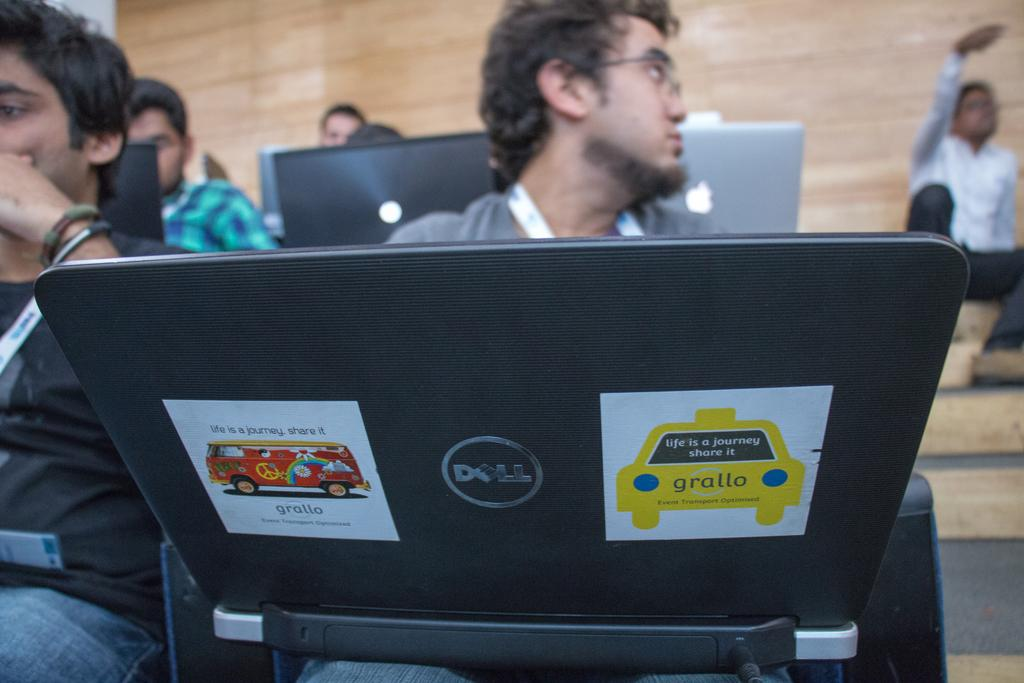What are the men in the image doing? The men in the image are sitting on chairs and holding laptops in their hands. Can you describe the position of the man on the right side of the image? There is a man sitting on the stairs on the right side of the image. What is visible in the background of the image? There is a wall in the background of the image. What type of argument is the man on the left side of the image having with his laptop? There is no man on the left side of the image, and there is no argument depicted in the image. What kind of breakfast is the man on the stairs eating? There is no breakfast present in the image; the man on the stairs is holding a laptop. 